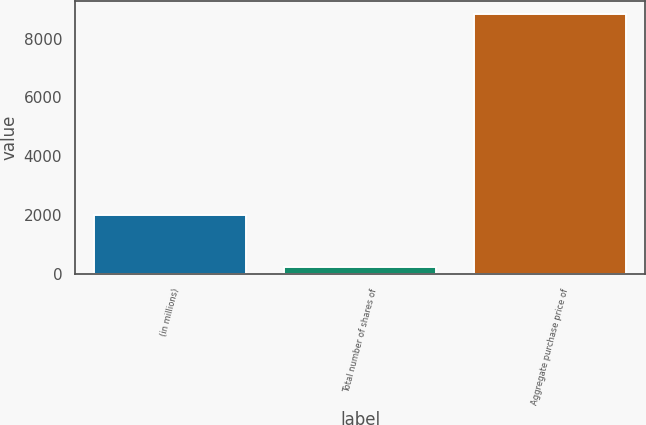Convert chart. <chart><loc_0><loc_0><loc_500><loc_500><bar_chart><fcel>(in millions)<fcel>Total number of shares of<fcel>Aggregate purchase price of<nl><fcel>2011<fcel>229<fcel>8827<nl></chart> 